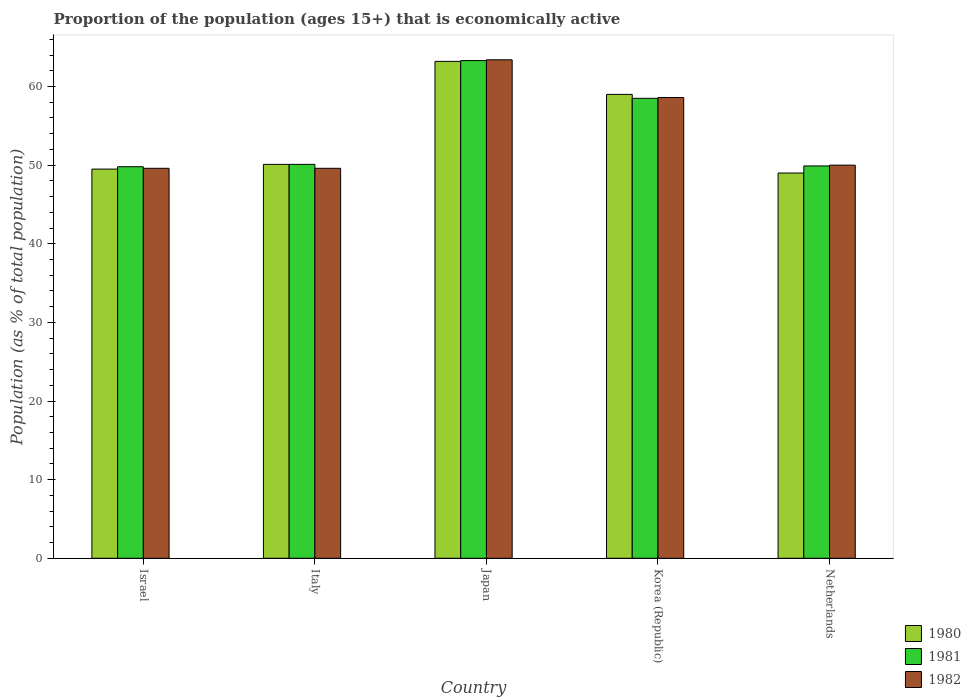How many different coloured bars are there?
Ensure brevity in your answer.  3. Are the number of bars per tick equal to the number of legend labels?
Offer a very short reply. Yes. Are the number of bars on each tick of the X-axis equal?
Your answer should be compact. Yes. What is the label of the 1st group of bars from the left?
Provide a short and direct response. Israel. In how many cases, is the number of bars for a given country not equal to the number of legend labels?
Ensure brevity in your answer.  0. What is the proportion of the population that is economically active in 1982 in Japan?
Provide a succinct answer. 63.4. Across all countries, what is the maximum proportion of the population that is economically active in 1980?
Your response must be concise. 63.2. Across all countries, what is the minimum proportion of the population that is economically active in 1982?
Provide a short and direct response. 49.6. What is the total proportion of the population that is economically active in 1980 in the graph?
Provide a short and direct response. 270.8. What is the difference between the proportion of the population that is economically active in 1981 in Italy and that in Japan?
Your response must be concise. -13.2. What is the difference between the proportion of the population that is economically active in 1981 in Israel and the proportion of the population that is economically active in 1980 in Netherlands?
Give a very brief answer. 0.8. What is the average proportion of the population that is economically active in 1980 per country?
Give a very brief answer. 54.16. What is the difference between the proportion of the population that is economically active of/in 1982 and proportion of the population that is economically active of/in 1980 in Korea (Republic)?
Keep it short and to the point. -0.4. In how many countries, is the proportion of the population that is economically active in 1981 greater than 52 %?
Ensure brevity in your answer.  2. What is the ratio of the proportion of the population that is economically active in 1981 in Japan to that in Korea (Republic)?
Your response must be concise. 1.08. Is the proportion of the population that is economically active in 1982 in Israel less than that in Japan?
Give a very brief answer. Yes. Is the difference between the proportion of the population that is economically active in 1982 in Israel and Italy greater than the difference between the proportion of the population that is economically active in 1980 in Israel and Italy?
Offer a terse response. Yes. What is the difference between the highest and the second highest proportion of the population that is economically active in 1980?
Ensure brevity in your answer.  -8.9. What is the difference between the highest and the lowest proportion of the population that is economically active in 1980?
Keep it short and to the point. 14.2. How many bars are there?
Make the answer very short. 15. How many countries are there in the graph?
Provide a short and direct response. 5. Are the values on the major ticks of Y-axis written in scientific E-notation?
Ensure brevity in your answer.  No. Does the graph contain any zero values?
Provide a succinct answer. No. How many legend labels are there?
Provide a succinct answer. 3. How are the legend labels stacked?
Provide a succinct answer. Vertical. What is the title of the graph?
Ensure brevity in your answer.  Proportion of the population (ages 15+) that is economically active. Does "2004" appear as one of the legend labels in the graph?
Offer a very short reply. No. What is the label or title of the X-axis?
Keep it short and to the point. Country. What is the label or title of the Y-axis?
Give a very brief answer. Population (as % of total population). What is the Population (as % of total population) of 1980 in Israel?
Your response must be concise. 49.5. What is the Population (as % of total population) in 1981 in Israel?
Provide a succinct answer. 49.8. What is the Population (as % of total population) in 1982 in Israel?
Make the answer very short. 49.6. What is the Population (as % of total population) in 1980 in Italy?
Provide a short and direct response. 50.1. What is the Population (as % of total population) of 1981 in Italy?
Your response must be concise. 50.1. What is the Population (as % of total population) of 1982 in Italy?
Offer a terse response. 49.6. What is the Population (as % of total population) in 1980 in Japan?
Give a very brief answer. 63.2. What is the Population (as % of total population) of 1981 in Japan?
Give a very brief answer. 63.3. What is the Population (as % of total population) of 1982 in Japan?
Provide a short and direct response. 63.4. What is the Population (as % of total population) of 1980 in Korea (Republic)?
Provide a short and direct response. 59. What is the Population (as % of total population) in 1981 in Korea (Republic)?
Ensure brevity in your answer.  58.5. What is the Population (as % of total population) in 1982 in Korea (Republic)?
Your answer should be very brief. 58.6. What is the Population (as % of total population) of 1981 in Netherlands?
Keep it short and to the point. 49.9. Across all countries, what is the maximum Population (as % of total population) of 1980?
Keep it short and to the point. 63.2. Across all countries, what is the maximum Population (as % of total population) of 1981?
Your response must be concise. 63.3. Across all countries, what is the maximum Population (as % of total population) in 1982?
Offer a terse response. 63.4. Across all countries, what is the minimum Population (as % of total population) in 1981?
Your response must be concise. 49.8. Across all countries, what is the minimum Population (as % of total population) in 1982?
Ensure brevity in your answer.  49.6. What is the total Population (as % of total population) in 1980 in the graph?
Ensure brevity in your answer.  270.8. What is the total Population (as % of total population) in 1981 in the graph?
Offer a terse response. 271.6. What is the total Population (as % of total population) in 1982 in the graph?
Your answer should be very brief. 271.2. What is the difference between the Population (as % of total population) of 1980 in Israel and that in Japan?
Your response must be concise. -13.7. What is the difference between the Population (as % of total population) in 1981 in Israel and that in Japan?
Make the answer very short. -13.5. What is the difference between the Population (as % of total population) in 1981 in Israel and that in Korea (Republic)?
Offer a terse response. -8.7. What is the difference between the Population (as % of total population) in 1982 in Israel and that in Korea (Republic)?
Your answer should be very brief. -9. What is the difference between the Population (as % of total population) of 1980 in Israel and that in Netherlands?
Ensure brevity in your answer.  0.5. What is the difference between the Population (as % of total population) of 1981 in Israel and that in Netherlands?
Provide a succinct answer. -0.1. What is the difference between the Population (as % of total population) in 1981 in Italy and that in Japan?
Provide a succinct answer. -13.2. What is the difference between the Population (as % of total population) of 1982 in Italy and that in Japan?
Offer a terse response. -13.8. What is the difference between the Population (as % of total population) in 1980 in Italy and that in Netherlands?
Ensure brevity in your answer.  1.1. What is the difference between the Population (as % of total population) of 1980 in Japan and that in Korea (Republic)?
Give a very brief answer. 4.2. What is the difference between the Population (as % of total population) in 1981 in Japan and that in Korea (Republic)?
Your answer should be very brief. 4.8. What is the difference between the Population (as % of total population) of 1982 in Japan and that in Korea (Republic)?
Provide a succinct answer. 4.8. What is the difference between the Population (as % of total population) in 1980 in Japan and that in Netherlands?
Keep it short and to the point. 14.2. What is the difference between the Population (as % of total population) in 1980 in Israel and the Population (as % of total population) in 1981 in Italy?
Provide a succinct answer. -0.6. What is the difference between the Population (as % of total population) of 1980 in Israel and the Population (as % of total population) of 1982 in Italy?
Your response must be concise. -0.1. What is the difference between the Population (as % of total population) in 1981 in Israel and the Population (as % of total population) in 1982 in Italy?
Offer a terse response. 0.2. What is the difference between the Population (as % of total population) of 1980 in Israel and the Population (as % of total population) of 1981 in Japan?
Provide a succinct answer. -13.8. What is the difference between the Population (as % of total population) of 1981 in Israel and the Population (as % of total population) of 1982 in Japan?
Offer a terse response. -13.6. What is the difference between the Population (as % of total population) in 1980 in Israel and the Population (as % of total population) in 1981 in Korea (Republic)?
Give a very brief answer. -9. What is the difference between the Population (as % of total population) of 1980 in Israel and the Population (as % of total population) of 1982 in Korea (Republic)?
Offer a very short reply. -9.1. What is the difference between the Population (as % of total population) in 1981 in Israel and the Population (as % of total population) in 1982 in Korea (Republic)?
Your answer should be very brief. -8.8. What is the difference between the Population (as % of total population) of 1980 in Israel and the Population (as % of total population) of 1981 in Netherlands?
Provide a short and direct response. -0.4. What is the difference between the Population (as % of total population) in 1981 in Israel and the Population (as % of total population) in 1982 in Netherlands?
Make the answer very short. -0.2. What is the difference between the Population (as % of total population) in 1981 in Italy and the Population (as % of total population) in 1982 in Japan?
Keep it short and to the point. -13.3. What is the difference between the Population (as % of total population) of 1980 in Italy and the Population (as % of total population) of 1982 in Korea (Republic)?
Your answer should be compact. -8.5. What is the difference between the Population (as % of total population) in 1981 in Italy and the Population (as % of total population) in 1982 in Korea (Republic)?
Offer a very short reply. -8.5. What is the difference between the Population (as % of total population) of 1980 in Japan and the Population (as % of total population) of 1982 in Korea (Republic)?
Ensure brevity in your answer.  4.6. What is the difference between the Population (as % of total population) of 1980 in Japan and the Population (as % of total population) of 1982 in Netherlands?
Your answer should be very brief. 13.2. What is the difference between the Population (as % of total population) in 1981 in Japan and the Population (as % of total population) in 1982 in Netherlands?
Give a very brief answer. 13.3. What is the difference between the Population (as % of total population) of 1981 in Korea (Republic) and the Population (as % of total population) of 1982 in Netherlands?
Keep it short and to the point. 8.5. What is the average Population (as % of total population) of 1980 per country?
Offer a terse response. 54.16. What is the average Population (as % of total population) in 1981 per country?
Offer a very short reply. 54.32. What is the average Population (as % of total population) of 1982 per country?
Offer a terse response. 54.24. What is the difference between the Population (as % of total population) of 1980 and Population (as % of total population) of 1981 in Israel?
Offer a very short reply. -0.3. What is the difference between the Population (as % of total population) in 1980 and Population (as % of total population) in 1982 in Italy?
Offer a very short reply. 0.5. What is the difference between the Population (as % of total population) of 1980 and Population (as % of total population) of 1981 in Japan?
Provide a short and direct response. -0.1. What is the difference between the Population (as % of total population) of 1981 and Population (as % of total population) of 1982 in Japan?
Offer a terse response. -0.1. What is the difference between the Population (as % of total population) of 1980 and Population (as % of total population) of 1982 in Korea (Republic)?
Your answer should be compact. 0.4. What is the difference between the Population (as % of total population) in 1981 and Population (as % of total population) in 1982 in Korea (Republic)?
Offer a very short reply. -0.1. What is the difference between the Population (as % of total population) in 1980 and Population (as % of total population) in 1982 in Netherlands?
Your response must be concise. -1. What is the ratio of the Population (as % of total population) of 1980 in Israel to that in Italy?
Provide a succinct answer. 0.99. What is the ratio of the Population (as % of total population) in 1982 in Israel to that in Italy?
Provide a succinct answer. 1. What is the ratio of the Population (as % of total population) in 1980 in Israel to that in Japan?
Your answer should be compact. 0.78. What is the ratio of the Population (as % of total population) in 1981 in Israel to that in Japan?
Your response must be concise. 0.79. What is the ratio of the Population (as % of total population) of 1982 in Israel to that in Japan?
Offer a very short reply. 0.78. What is the ratio of the Population (as % of total population) in 1980 in Israel to that in Korea (Republic)?
Offer a very short reply. 0.84. What is the ratio of the Population (as % of total population) in 1981 in Israel to that in Korea (Republic)?
Offer a terse response. 0.85. What is the ratio of the Population (as % of total population) in 1982 in Israel to that in Korea (Republic)?
Your answer should be compact. 0.85. What is the ratio of the Population (as % of total population) in 1980 in Israel to that in Netherlands?
Offer a very short reply. 1.01. What is the ratio of the Population (as % of total population) of 1981 in Israel to that in Netherlands?
Provide a succinct answer. 1. What is the ratio of the Population (as % of total population) in 1980 in Italy to that in Japan?
Your answer should be compact. 0.79. What is the ratio of the Population (as % of total population) of 1981 in Italy to that in Japan?
Give a very brief answer. 0.79. What is the ratio of the Population (as % of total population) in 1982 in Italy to that in Japan?
Ensure brevity in your answer.  0.78. What is the ratio of the Population (as % of total population) in 1980 in Italy to that in Korea (Republic)?
Offer a terse response. 0.85. What is the ratio of the Population (as % of total population) of 1981 in Italy to that in Korea (Republic)?
Your answer should be very brief. 0.86. What is the ratio of the Population (as % of total population) of 1982 in Italy to that in Korea (Republic)?
Your answer should be very brief. 0.85. What is the ratio of the Population (as % of total population) in 1980 in Italy to that in Netherlands?
Ensure brevity in your answer.  1.02. What is the ratio of the Population (as % of total population) of 1980 in Japan to that in Korea (Republic)?
Give a very brief answer. 1.07. What is the ratio of the Population (as % of total population) in 1981 in Japan to that in Korea (Republic)?
Your answer should be very brief. 1.08. What is the ratio of the Population (as % of total population) in 1982 in Japan to that in Korea (Republic)?
Offer a very short reply. 1.08. What is the ratio of the Population (as % of total population) in 1980 in Japan to that in Netherlands?
Make the answer very short. 1.29. What is the ratio of the Population (as % of total population) of 1981 in Japan to that in Netherlands?
Make the answer very short. 1.27. What is the ratio of the Population (as % of total population) in 1982 in Japan to that in Netherlands?
Your answer should be compact. 1.27. What is the ratio of the Population (as % of total population) of 1980 in Korea (Republic) to that in Netherlands?
Your answer should be very brief. 1.2. What is the ratio of the Population (as % of total population) in 1981 in Korea (Republic) to that in Netherlands?
Ensure brevity in your answer.  1.17. What is the ratio of the Population (as % of total population) of 1982 in Korea (Republic) to that in Netherlands?
Offer a terse response. 1.17. What is the difference between the highest and the second highest Population (as % of total population) in 1982?
Ensure brevity in your answer.  4.8. What is the difference between the highest and the lowest Population (as % of total population) of 1980?
Provide a short and direct response. 14.2. What is the difference between the highest and the lowest Population (as % of total population) of 1982?
Offer a very short reply. 13.8. 